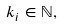<formula> <loc_0><loc_0><loc_500><loc_500>\, k _ { i } \in \mathbb { N } ,</formula> 